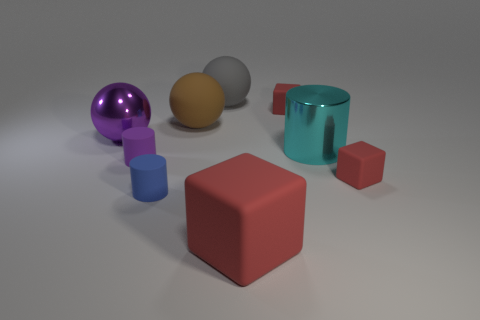Are there more brown spheres that are in front of the purple metal sphere than tiny gray metal blocks?
Give a very brief answer. No. What is the small object on the left side of the blue matte cylinder made of?
Provide a succinct answer. Rubber. What number of gray things are the same material as the tiny blue object?
Keep it short and to the point. 1. The red object that is behind the tiny blue matte cylinder and in front of the large purple object has what shape?
Provide a short and direct response. Cube. What number of objects are either red blocks that are in front of the metallic cylinder or rubber cubes right of the big metallic cylinder?
Your answer should be compact. 2. Are there an equal number of large cyan cylinders in front of the purple rubber cylinder and cyan shiny cylinders that are on the right side of the big cube?
Ensure brevity in your answer.  No. There is a small blue object right of the big metallic object that is to the left of the big gray object; what is its shape?
Provide a succinct answer. Cylinder. Are there any purple metallic objects of the same shape as the small blue matte object?
Offer a terse response. No. What number of yellow blocks are there?
Ensure brevity in your answer.  0. Are the cube that is behind the big purple thing and the small purple object made of the same material?
Make the answer very short. Yes. 